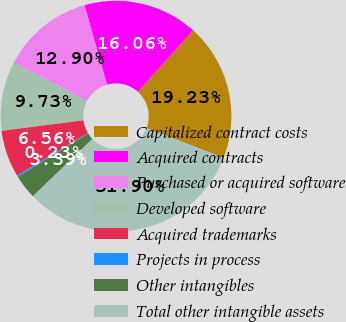Convert chart to OTSL. <chart><loc_0><loc_0><loc_500><loc_500><pie_chart><fcel>Capitalized contract costs<fcel>Acquired contracts<fcel>Purchased or acquired software<fcel>Developed software<fcel>Acquired trademarks<fcel>Projects in process<fcel>Other intangibles<fcel>Total other intangible assets<nl><fcel>19.23%<fcel>16.06%<fcel>12.9%<fcel>9.73%<fcel>6.56%<fcel>0.23%<fcel>3.39%<fcel>31.9%<nl></chart> 